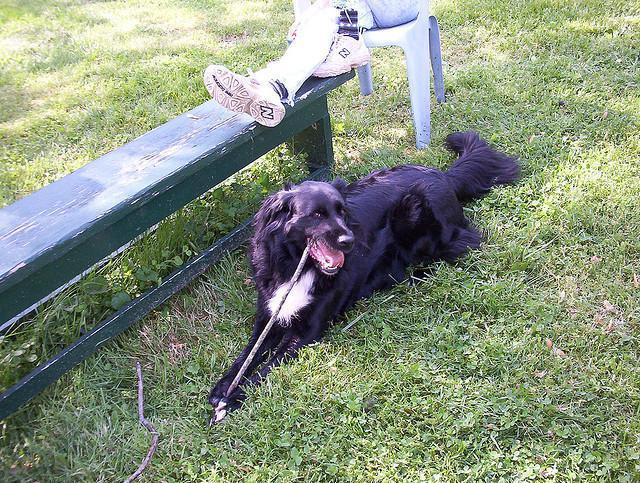How many birds are standing on the sidewalk?
Give a very brief answer. 0. 